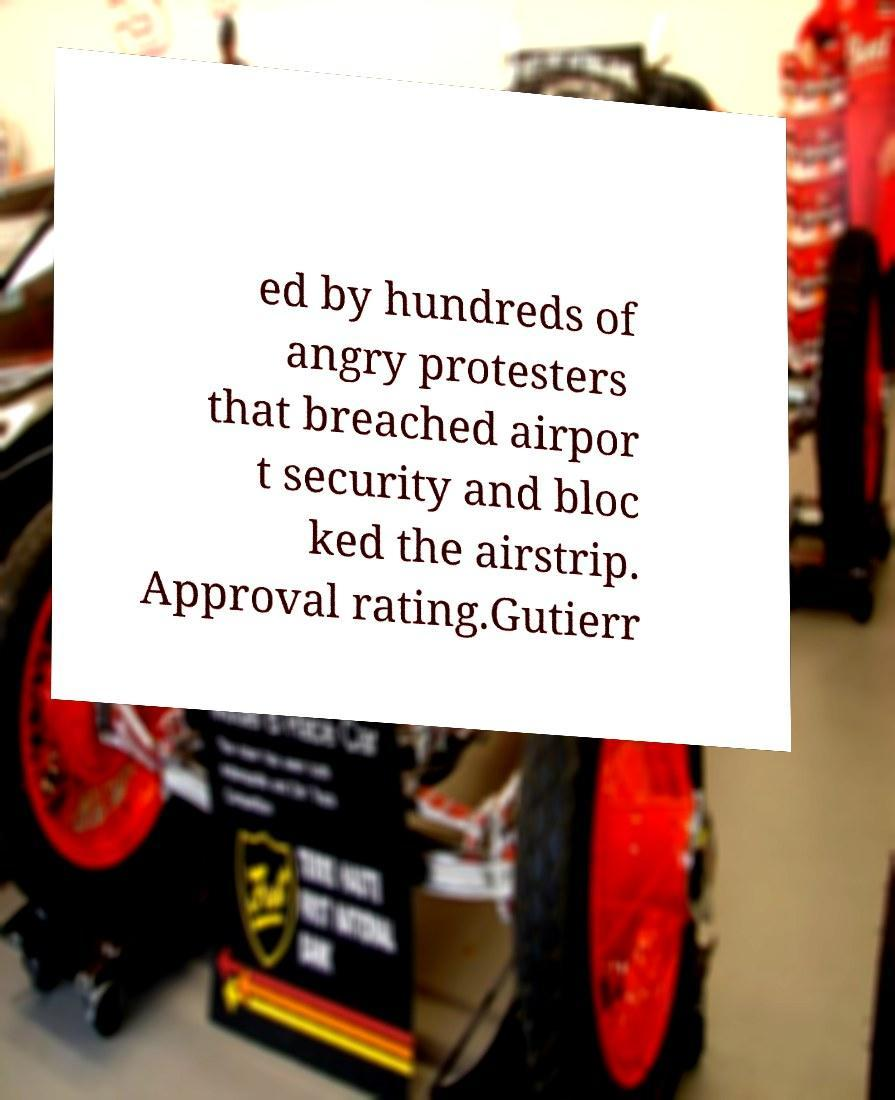Please identify and transcribe the text found in this image. ed by hundreds of angry protesters that breached airpor t security and bloc ked the airstrip. Approval rating.Gutierr 